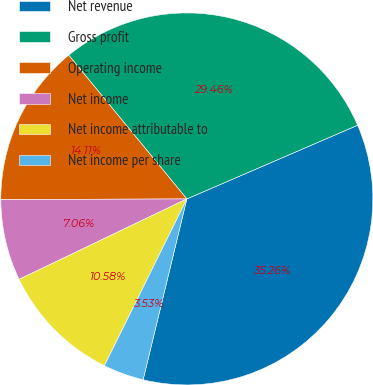<chart> <loc_0><loc_0><loc_500><loc_500><pie_chart><fcel>Net revenue<fcel>Gross profit<fcel>Operating income<fcel>Net income<fcel>Net income attributable to<fcel>Net income per share<nl><fcel>35.26%<fcel>29.46%<fcel>14.11%<fcel>7.06%<fcel>10.58%<fcel>3.53%<nl></chart> 